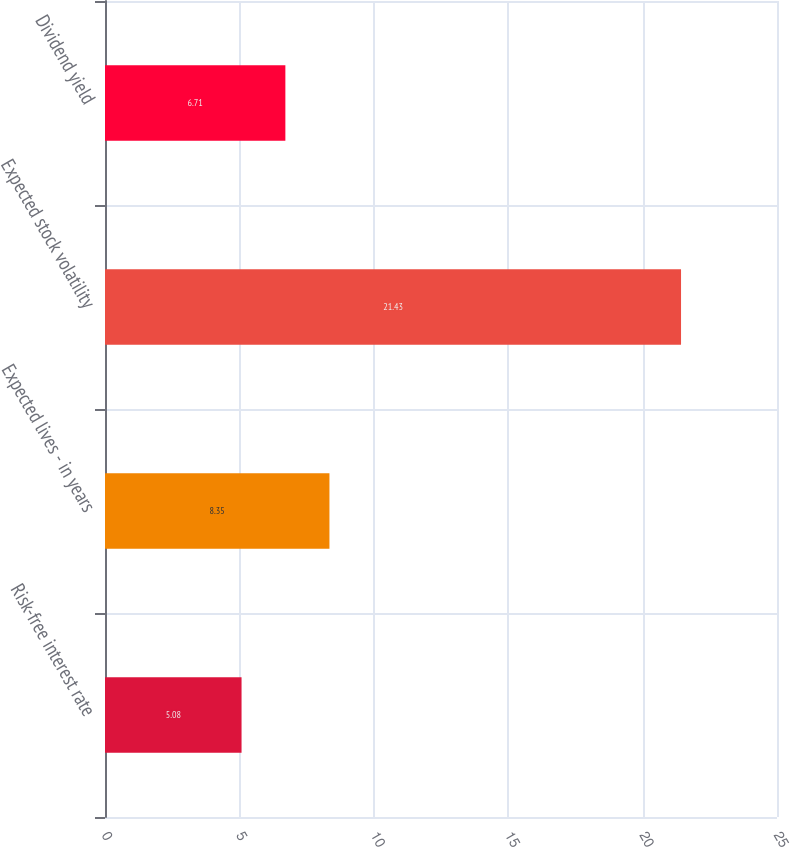Convert chart. <chart><loc_0><loc_0><loc_500><loc_500><bar_chart><fcel>Risk-free interest rate<fcel>Expected lives - in years<fcel>Expected stock volatility<fcel>Dividend yield<nl><fcel>5.08<fcel>8.35<fcel>21.43<fcel>6.71<nl></chart> 